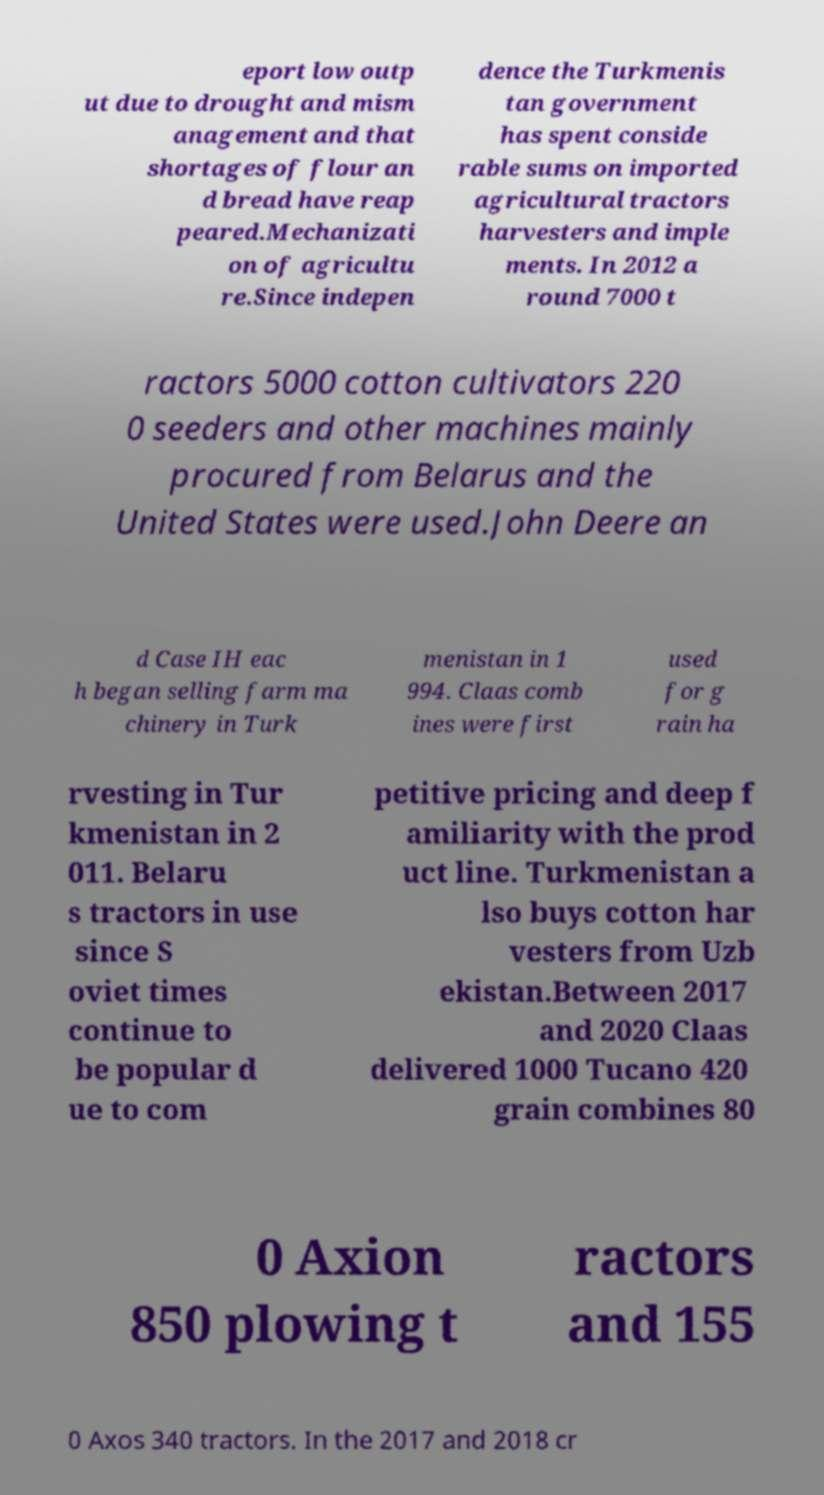Please read and relay the text visible in this image. What does it say? eport low outp ut due to drought and mism anagement and that shortages of flour an d bread have reap peared.Mechanizati on of agricultu re.Since indepen dence the Turkmenis tan government has spent conside rable sums on imported agricultural tractors harvesters and imple ments. In 2012 a round 7000 t ractors 5000 cotton cultivators 220 0 seeders and other machines mainly procured from Belarus and the United States were used.John Deere an d Case IH eac h began selling farm ma chinery in Turk menistan in 1 994. Claas comb ines were first used for g rain ha rvesting in Tur kmenistan in 2 011. Belaru s tractors in use since S oviet times continue to be popular d ue to com petitive pricing and deep f amiliarity with the prod uct line. Turkmenistan a lso buys cotton har vesters from Uzb ekistan.Between 2017 and 2020 Claas delivered 1000 Tucano 420 grain combines 80 0 Axion 850 plowing t ractors and 155 0 Axos 340 tractors. In the 2017 and 2018 cr 